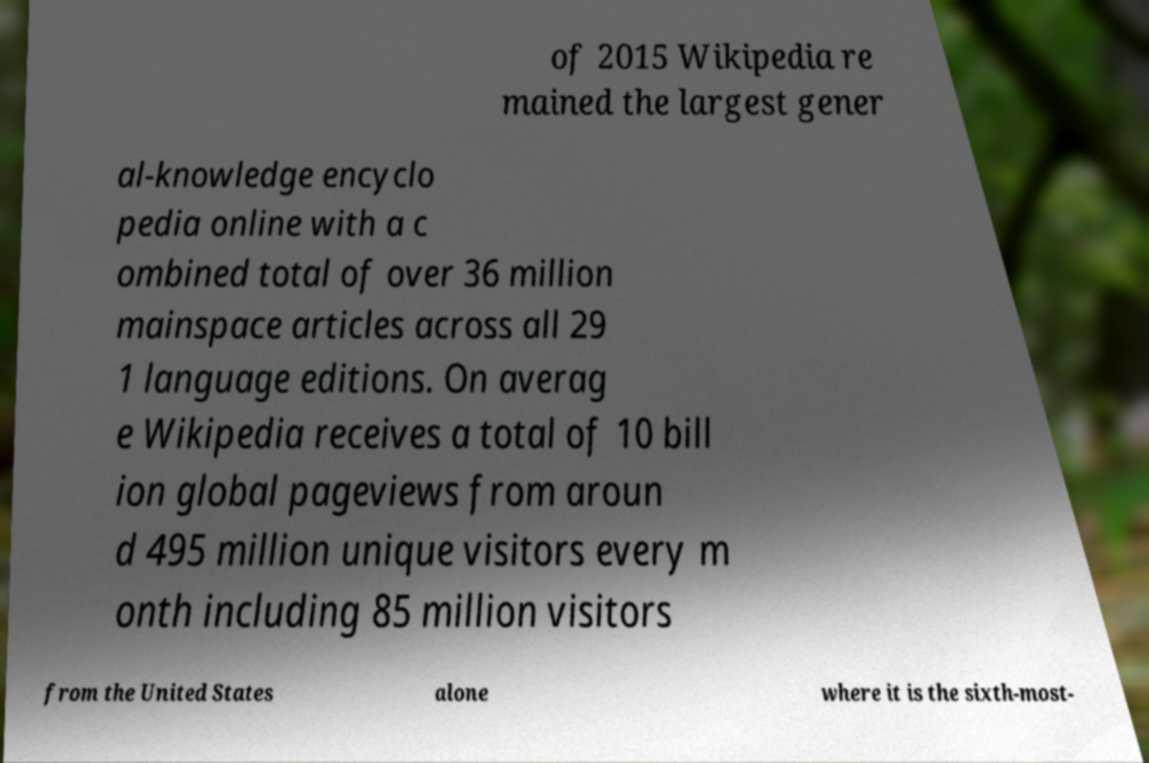Can you read and provide the text displayed in the image?This photo seems to have some interesting text. Can you extract and type it out for me? of 2015 Wikipedia re mained the largest gener al-knowledge encyclo pedia online with a c ombined total of over 36 million mainspace articles across all 29 1 language editions. On averag e Wikipedia receives a total of 10 bill ion global pageviews from aroun d 495 million unique visitors every m onth including 85 million visitors from the United States alone where it is the sixth-most- 